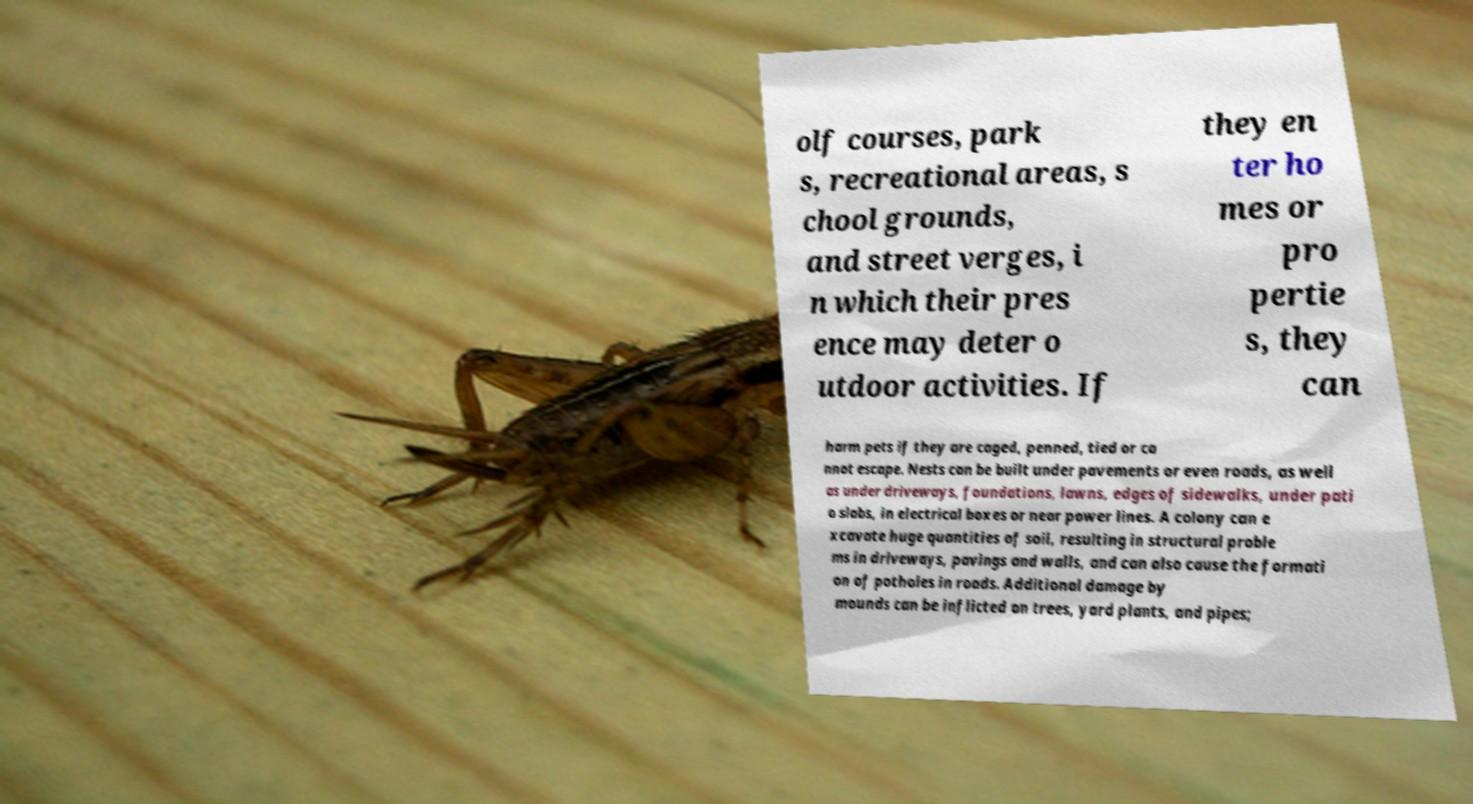Could you assist in decoding the text presented in this image and type it out clearly? olf courses, park s, recreational areas, s chool grounds, and street verges, i n which their pres ence may deter o utdoor activities. If they en ter ho mes or pro pertie s, they can harm pets if they are caged, penned, tied or ca nnot escape. Nests can be built under pavements or even roads, as well as under driveways, foundations, lawns, edges of sidewalks, under pati o slabs, in electrical boxes or near power lines. A colony can e xcavate huge quantities of soil, resulting in structural proble ms in driveways, pavings and walls, and can also cause the formati on of potholes in roads. Additional damage by mounds can be inflicted on trees, yard plants, and pipes; 